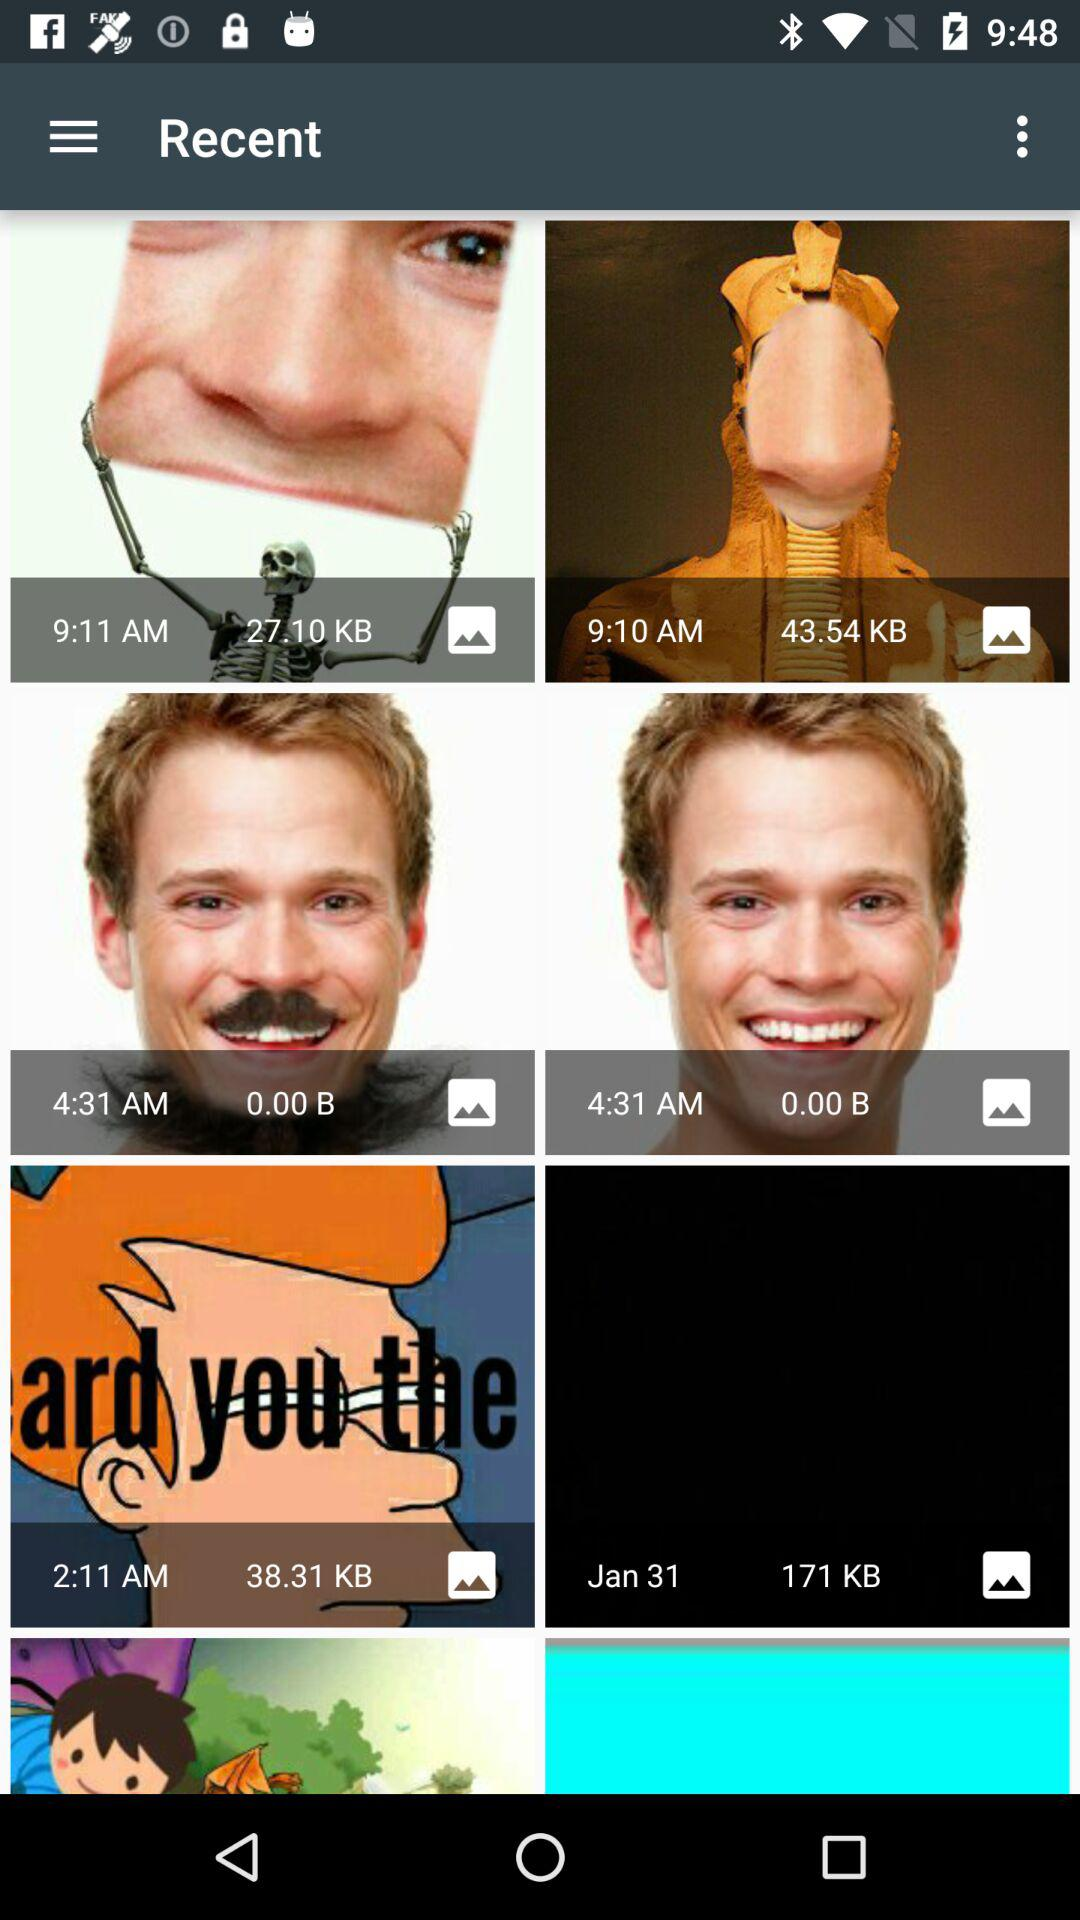What is the size of the image taken on January 31? The size of the image taken on January 31 is 171 KB. 